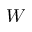Convert formula to latex. <formula><loc_0><loc_0><loc_500><loc_500>W</formula> 